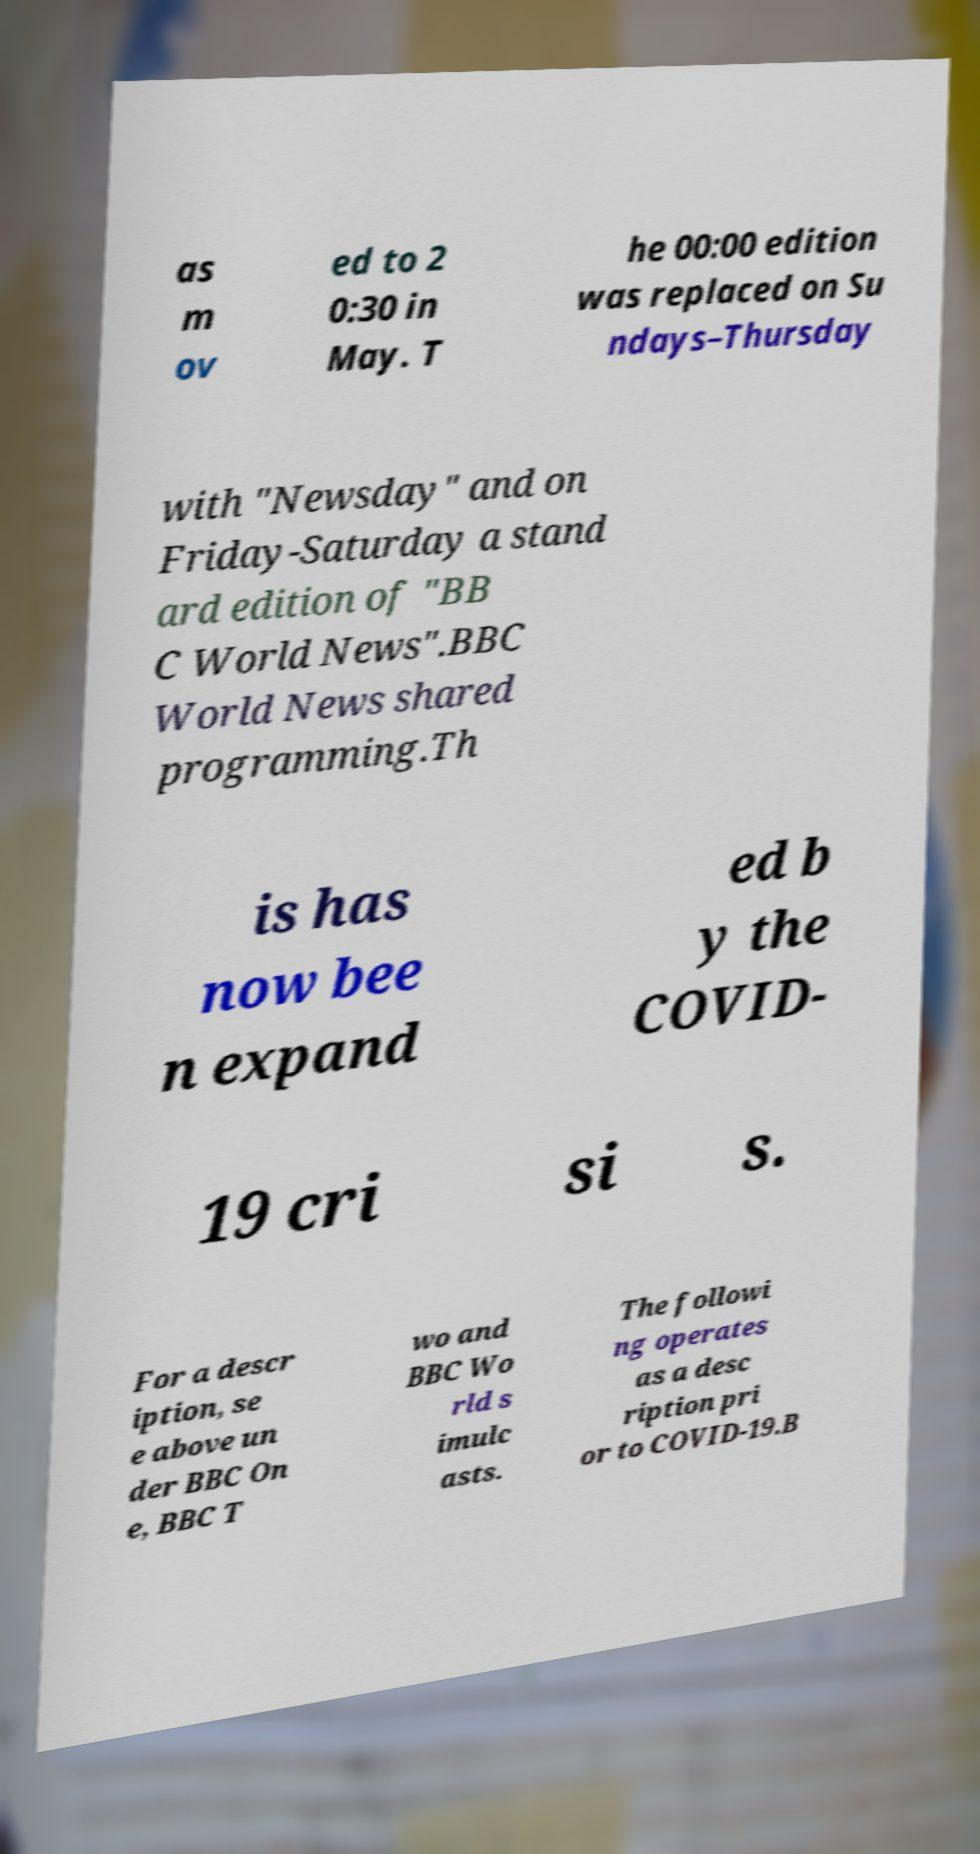There's text embedded in this image that I need extracted. Can you transcribe it verbatim? as m ov ed to 2 0:30 in May. T he 00:00 edition was replaced on Su ndays–Thursday with "Newsday" and on Friday-Saturday a stand ard edition of "BB C World News".BBC World News shared programming.Th is has now bee n expand ed b y the COVID- 19 cri si s. For a descr iption, se e above un der BBC On e, BBC T wo and BBC Wo rld s imulc asts. The followi ng operates as a desc ription pri or to COVID-19.B 